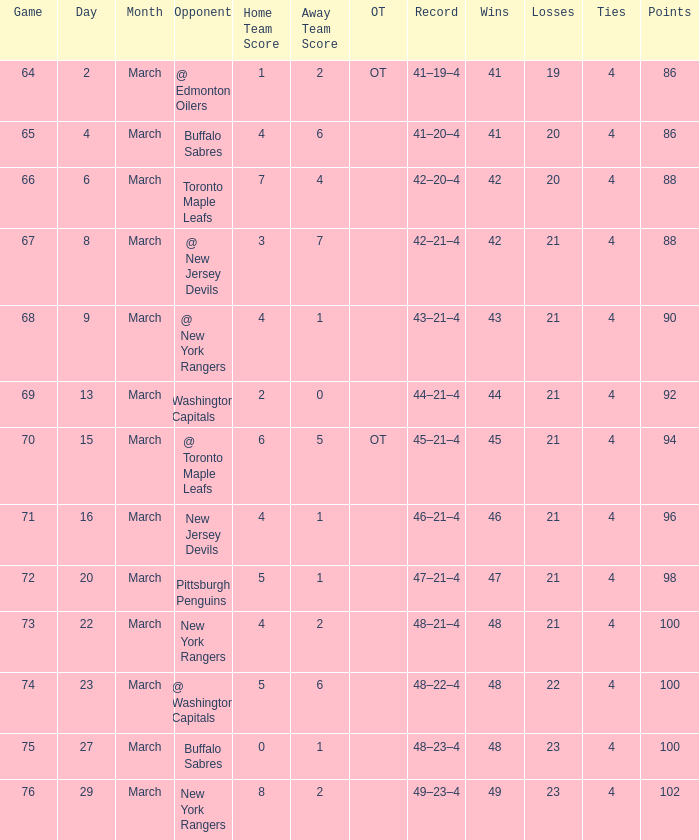Which Points have a Record of 45–21–4, and a Game larger than 70? None. 